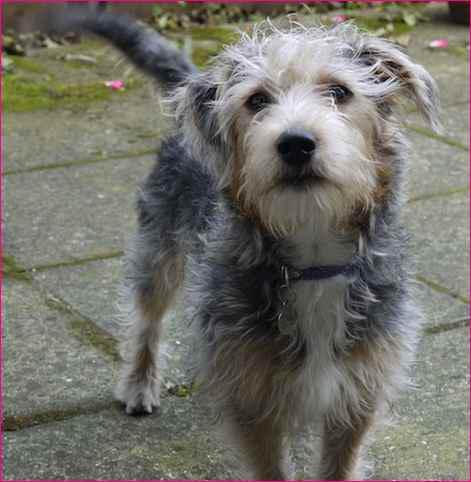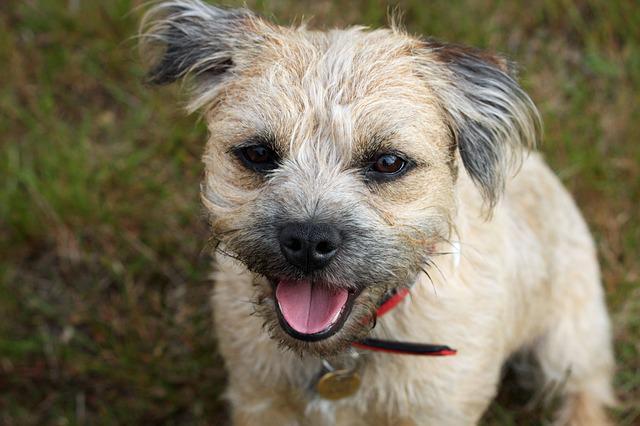The first image is the image on the left, the second image is the image on the right. Examine the images to the left and right. Is the description "All the dogs have a visible collar on." accurate? Answer yes or no. Yes. The first image is the image on the left, the second image is the image on the right. For the images displayed, is the sentence "a circular metal dog tag is attached to the dogs collar" factually correct? Answer yes or no. Yes. 